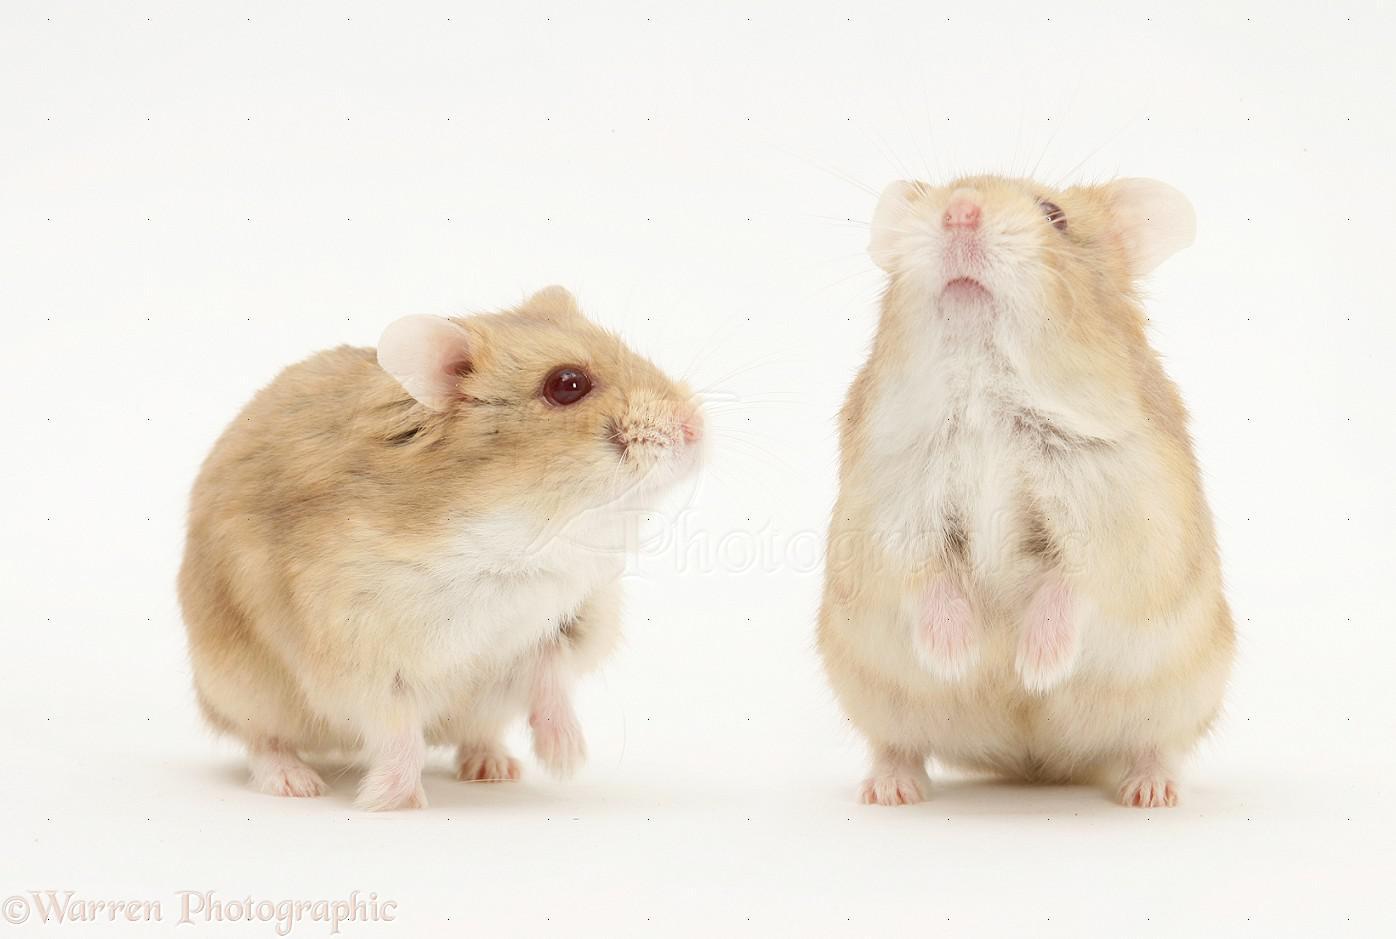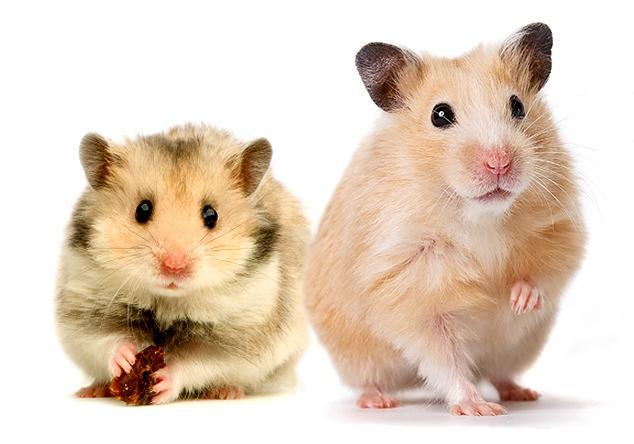The first image is the image on the left, the second image is the image on the right. Given the left and right images, does the statement "At least one hamster is eating a piece of carrot." hold true? Answer yes or no. No. The first image is the image on the left, the second image is the image on the right. Analyze the images presented: Is the assertion "None of these rodents is snacking on a carrot slice." valid? Answer yes or no. Yes. 